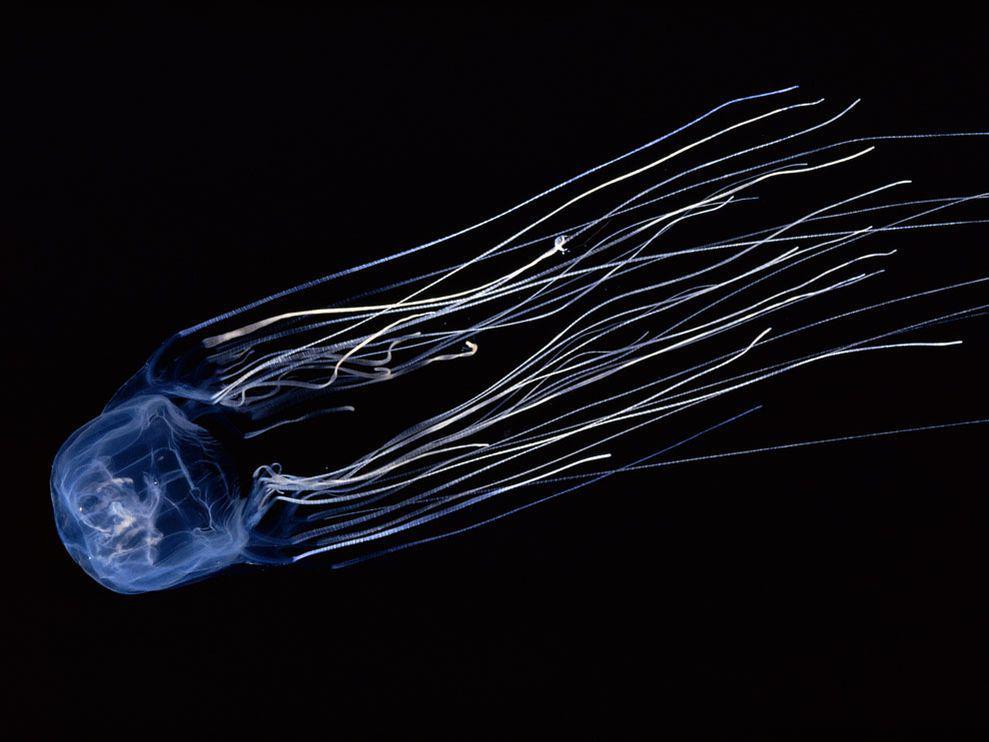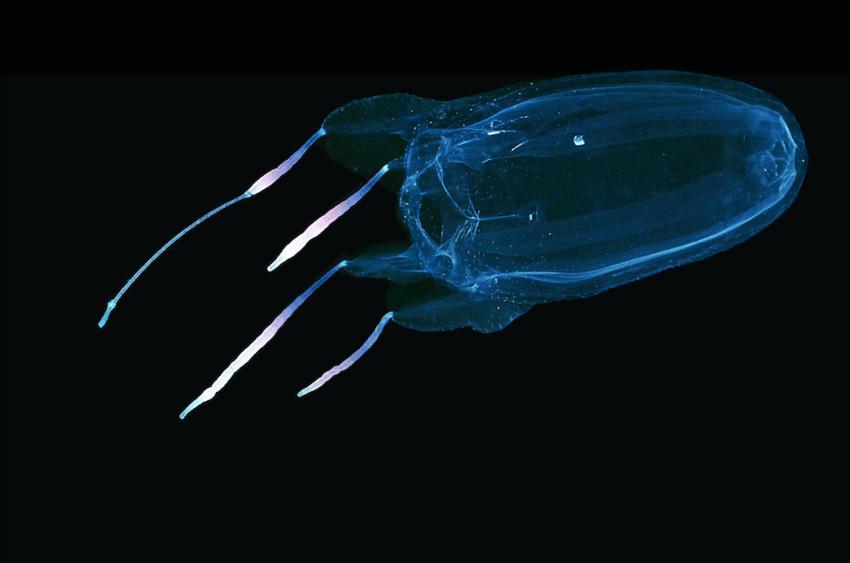The first image is the image on the left, the second image is the image on the right. Given the left and right images, does the statement "in the left image the jellyfish is swimming straight up" hold true? Answer yes or no. No. The first image is the image on the left, the second image is the image on the right. For the images displayed, is the sentence "Both images show a single jellyfish with a black background." factually correct? Answer yes or no. Yes. 